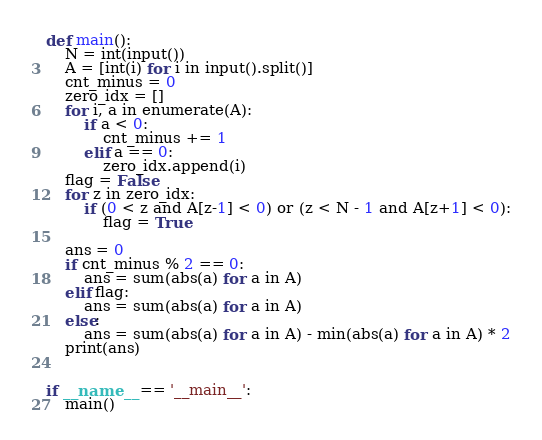Convert code to text. <code><loc_0><loc_0><loc_500><loc_500><_Python_>def main():
    N = int(input())
    A = [int(i) for i in input().split()]
    cnt_minus = 0
    zero_idx = []
    for i, a in enumerate(A):
        if a < 0:
            cnt_minus += 1
        elif a == 0:
            zero_idx.append(i)
    flag = False
    for z in zero_idx:
        if (0 < z and A[z-1] < 0) or (z < N - 1 and A[z+1] < 0):
            flag = True

    ans = 0
    if cnt_minus % 2 == 0:
        ans = sum(abs(a) for a in A)
    elif flag:
        ans = sum(abs(a) for a in A)
    else:
        ans = sum(abs(a) for a in A) - min(abs(a) for a in A) * 2
    print(ans)


if __name__ == '__main__':
    main()
</code> 